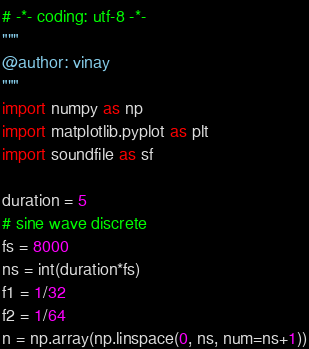<code> <loc_0><loc_0><loc_500><loc_500><_Python_># -*- coding: utf-8 -*-
"""
@author: vinay
"""
import numpy as np
import matplotlib.pyplot as plt
import soundfile as sf

duration = 5
# sine wave discrete
fs = 8000
ns = int(duration*fs)
f1 = 1/32
f2 = 1/64
n = np.array(np.linspace(0, ns, num=ns+1))</code> 